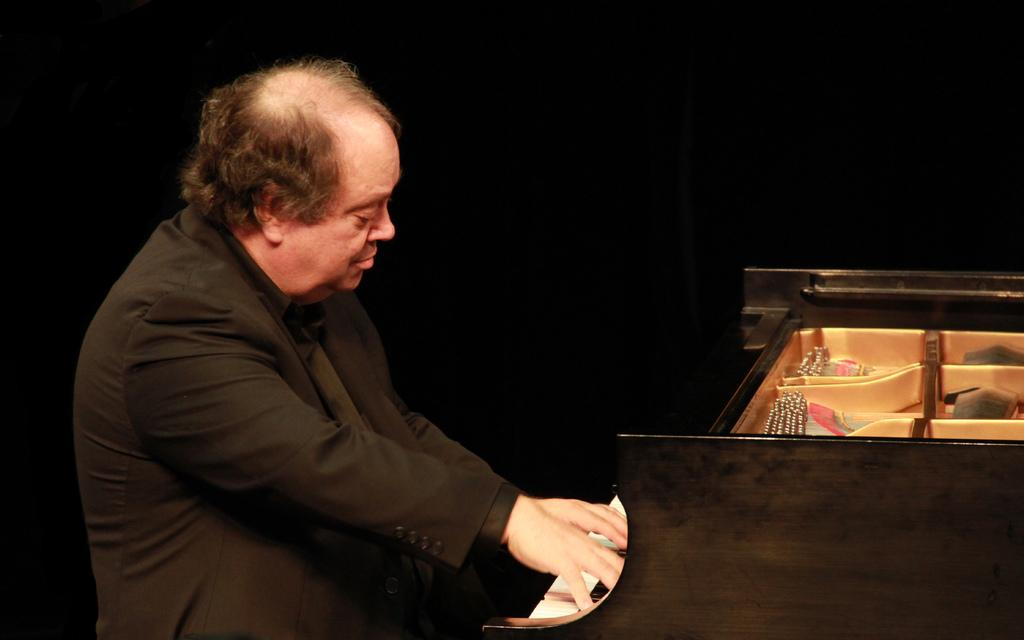Who is the person in the image? There is a man in the image. Where is the man located in the image? The man is on the left side of the image. What is the man doing in the image? The man is playing the piano. Where is the piano located in the image? The piano is on the right side of the image. What is the color of the background in the image? The background color of the image is black. Can you describe the sense of smell in the image? There is no information about the sense of smell in the image, as it only features a man playing the piano on the left side and a piano on the right side, with a black background. 